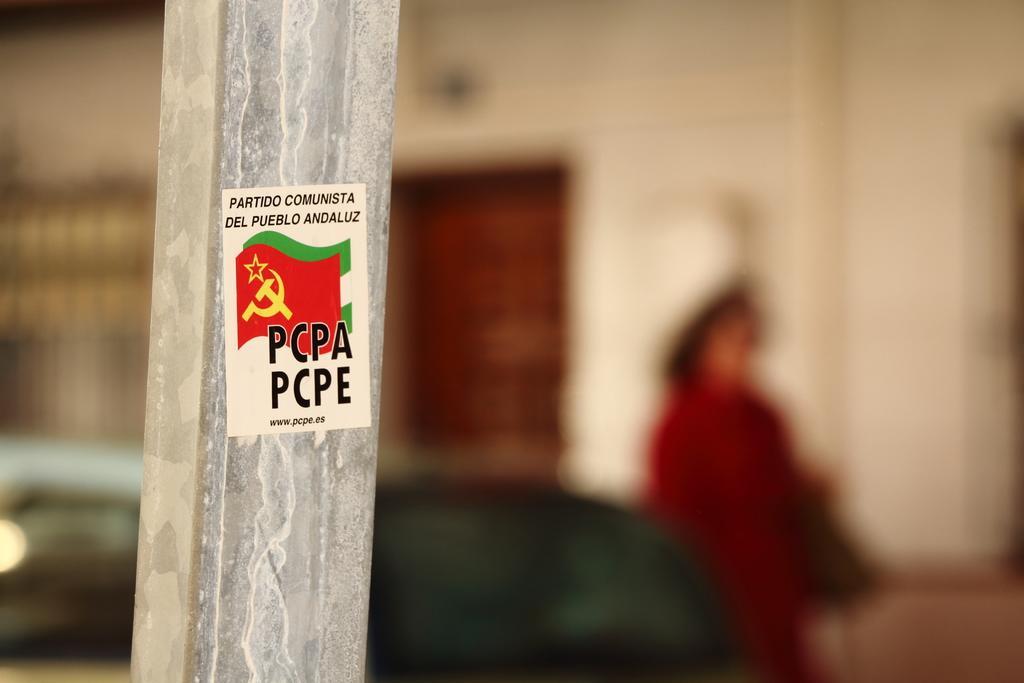How would you summarize this image in a sentence or two? There is a sticker on which, there are texts and flags on the pole. In the background, there is a person near a building. And the background is blurred. 